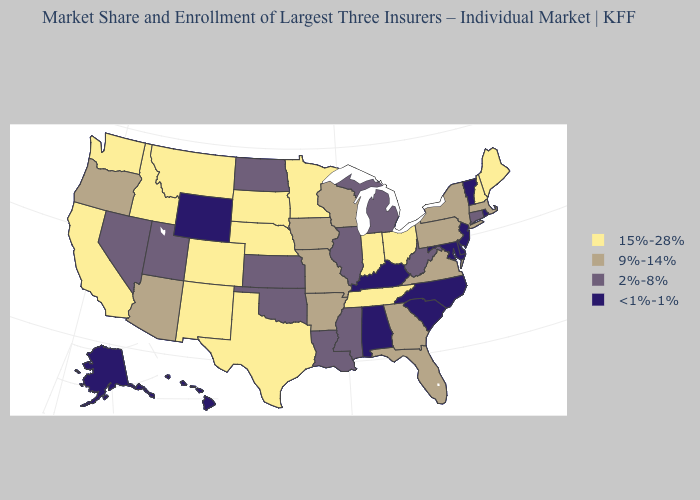Name the states that have a value in the range 2%-8%?
Short answer required. Connecticut, Illinois, Kansas, Louisiana, Michigan, Mississippi, Nevada, North Dakota, Oklahoma, Utah, West Virginia. Which states hav the highest value in the South?
Short answer required. Tennessee, Texas. What is the lowest value in the USA?
Answer briefly. <1%-1%. Name the states that have a value in the range 15%-28%?
Concise answer only. California, Colorado, Idaho, Indiana, Maine, Minnesota, Montana, Nebraska, New Hampshire, New Mexico, Ohio, South Dakota, Tennessee, Texas, Washington. Name the states that have a value in the range <1%-1%?
Give a very brief answer. Alabama, Alaska, Delaware, Hawaii, Kentucky, Maryland, New Jersey, North Carolina, Rhode Island, South Carolina, Vermont, Wyoming. What is the highest value in states that border Missouri?
Answer briefly. 15%-28%. What is the value of Idaho?
Answer briefly. 15%-28%. Name the states that have a value in the range 15%-28%?
Give a very brief answer. California, Colorado, Idaho, Indiana, Maine, Minnesota, Montana, Nebraska, New Hampshire, New Mexico, Ohio, South Dakota, Tennessee, Texas, Washington. Name the states that have a value in the range 2%-8%?
Be succinct. Connecticut, Illinois, Kansas, Louisiana, Michigan, Mississippi, Nevada, North Dakota, Oklahoma, Utah, West Virginia. Among the states that border Delaware , does Pennsylvania have the highest value?
Quick response, please. Yes. What is the value of Kansas?
Give a very brief answer. 2%-8%. What is the value of Colorado?
Keep it brief. 15%-28%. What is the lowest value in the USA?
Concise answer only. <1%-1%. How many symbols are there in the legend?
Concise answer only. 4. Is the legend a continuous bar?
Concise answer only. No. 